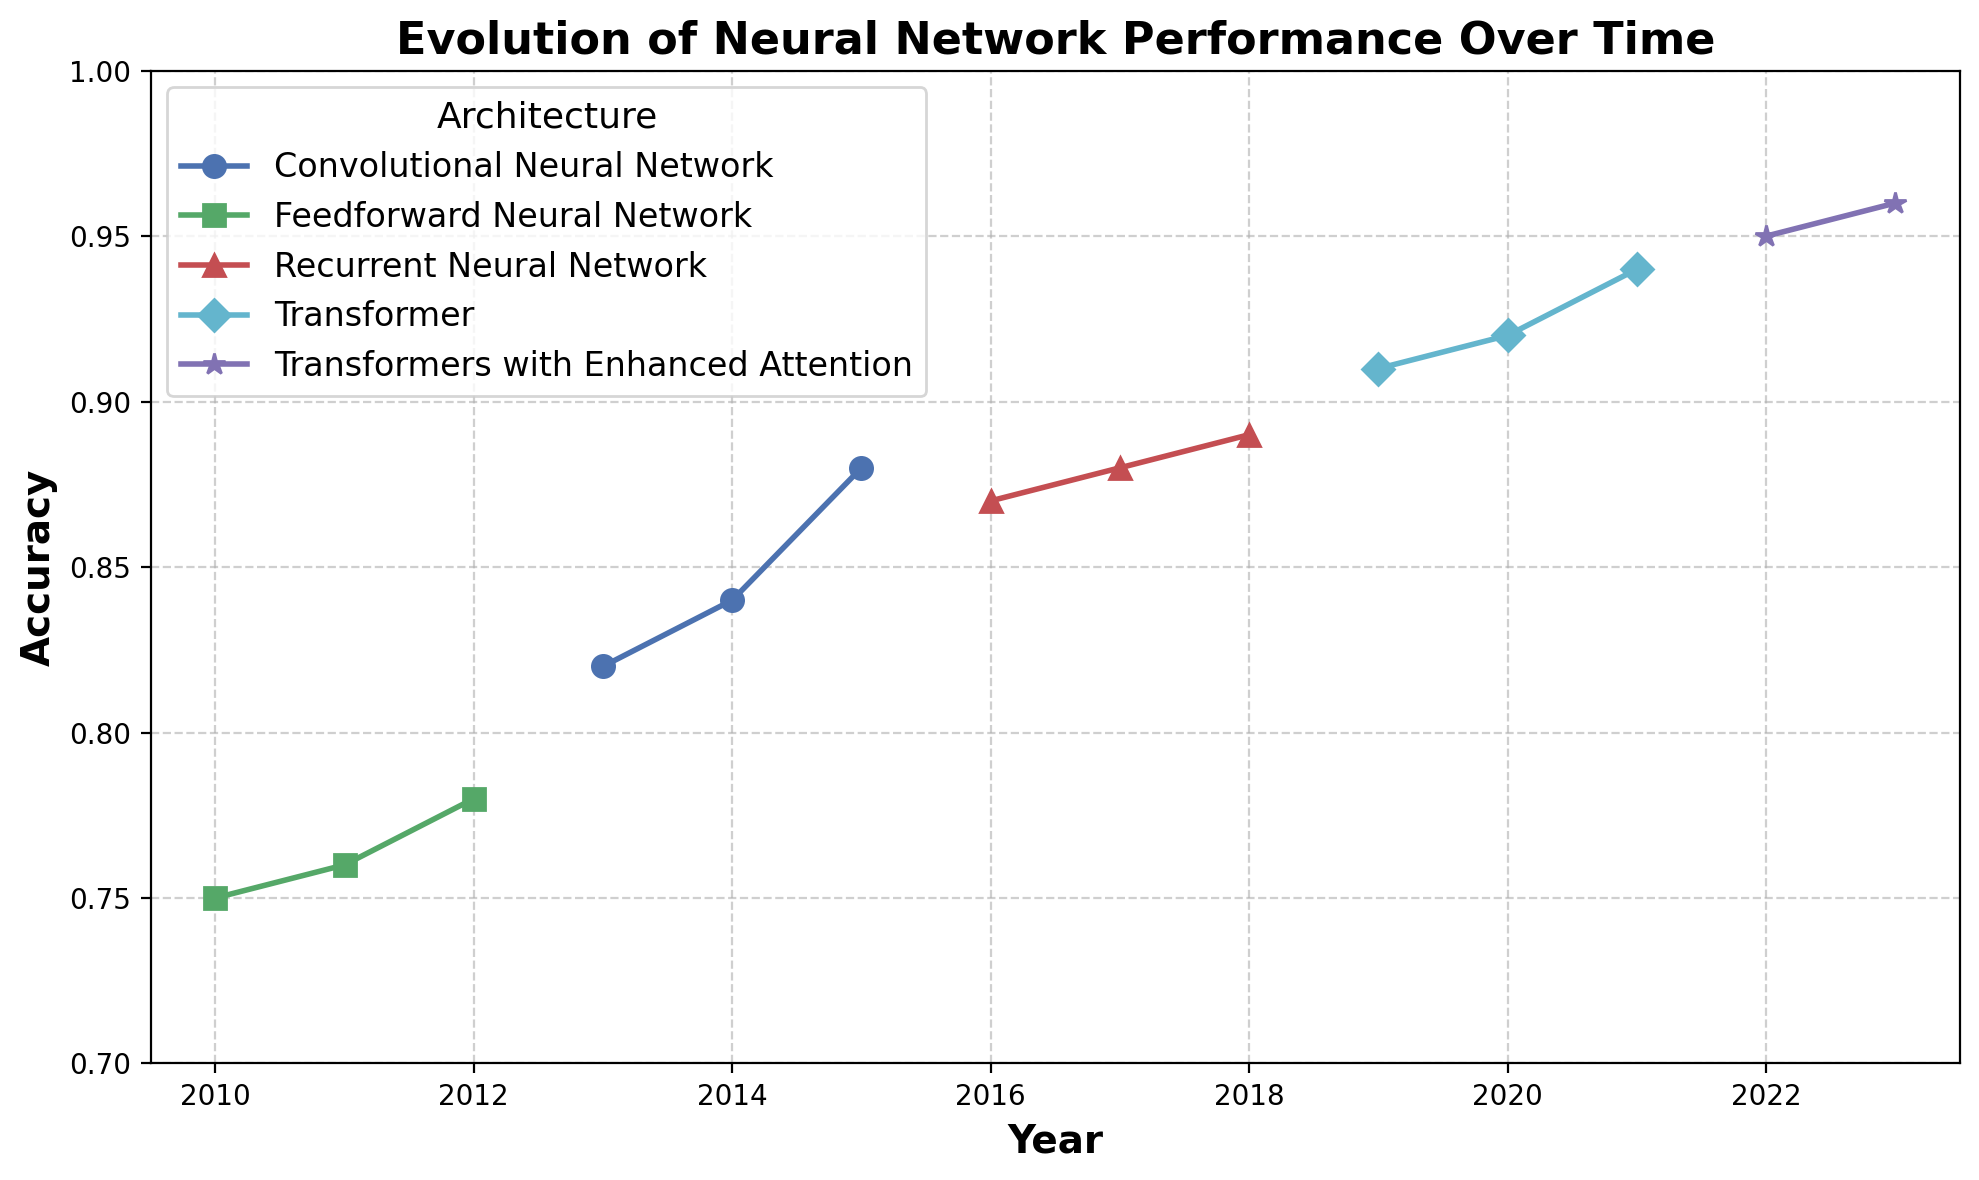Which architecture shows the biggest improvement in accuracy over time? Observe the range of accuracy for each architecture by measuring the difference between the final and initial values in their respective time periods. The Transformers with Enhanced Attention show an increase from 0.91 in 2019 to 0.96 in 2023, a total of 0.05 improvement, which is the largest range observed.
Answer: Transformers with Enhanced Attention Which architecture had the highest accuracy in 2013? Look at the data points for the year 2013. The accuracy for Convolutional Neural Network is 0.82, the only architecture noted for that year.
Answer: Convolutional Neural Network Between 2020 and 2021, which architecture showed a greater increase in accuracy? Compare the accuracy of each architecture between the years 2020 and 2021. For Transformers, the accuracy increased from 0.92 to 0.94, a difference of 0.02. For other architectures, no changes are reported. Hence, Transformers show the greater increase.
Answer: Transformers What is the average accuracy of the Recurrent Neural Network over its observed period? Recurrent Neural Network's accuracies over 2016-2018 are 0.87, 0.88, and 0.89. Calculate their average: (0.87 + 0.88 + 0.89) / 3 = 0.88
Answer: 0.88 Which architecture shows a decline in accuracy at any point in time? Survey each line to find any drops in the plotted points over time. There is no architecture that demonstrates a decline in accuracy in the given data set.
Answer: None How does the performance of the Feedforward Neural Network in 2012 compare to the Transformers with Enhanced Attention in 2023? Find and compare the plotted points for the Feedforward Neural Network in 2012 (0.78) and the Transformers with Enhanced Attention in 2023 (0.96). Clearly, the latter surpasses the former.
Answer: Transformers with Enhanced Attention in 2023 are higher What was the accuracy increase for Convolutional Neural Networks from 2013 to 2015? Check the values for the Convolutional Neural Network in 2013 (0.82) and 2015 (0.88). The increase is 0.88 - 0.82 = 0.06
Answer: 0.06 List the architectures in order of their appearance on the plot. Follow the chronological sequence of the architectures' representations starting from the earliest year on the x-axis: Feedforward Neural Network, Convolutional Neural Network, Recurrent Neural Network, Transformer, Transformers with Enhanced Attention.
Answer: Feedforward Neural Network, Convolutional Neural Network, Recurrent Neural Network, Transformer, Transformers with Enhanced Attention 